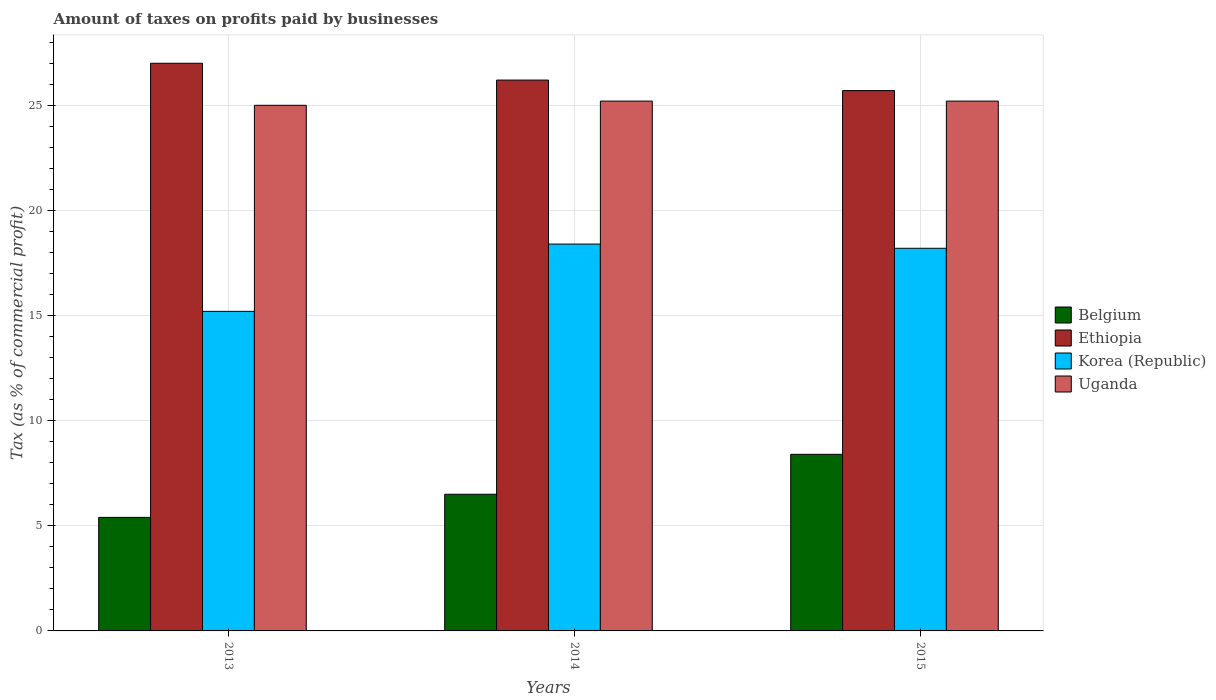Are the number of bars per tick equal to the number of legend labels?
Your answer should be very brief. Yes. Are the number of bars on each tick of the X-axis equal?
Your answer should be very brief. Yes. How many bars are there on the 2nd tick from the left?
Provide a succinct answer. 4. How many bars are there on the 1st tick from the right?
Your response must be concise. 4. What is the label of the 2nd group of bars from the left?
Make the answer very short. 2014. What is the percentage of taxes paid by businesses in Uganda in 2014?
Give a very brief answer. 25.2. In which year was the percentage of taxes paid by businesses in Uganda maximum?
Ensure brevity in your answer.  2014. In which year was the percentage of taxes paid by businesses in Ethiopia minimum?
Provide a succinct answer. 2015. What is the total percentage of taxes paid by businesses in Belgium in the graph?
Offer a terse response. 20.3. What is the difference between the percentage of taxes paid by businesses in Uganda in 2014 and that in 2015?
Your response must be concise. 0. What is the difference between the percentage of taxes paid by businesses in Ethiopia in 2015 and the percentage of taxes paid by businesses in Uganda in 2014?
Give a very brief answer. 0.5. What is the average percentage of taxes paid by businesses in Belgium per year?
Your answer should be compact. 6.77. In how many years, is the percentage of taxes paid by businesses in Belgium greater than 10 %?
Offer a very short reply. 0. What is the ratio of the percentage of taxes paid by businesses in Ethiopia in 2014 to that in 2015?
Give a very brief answer. 1.02. Is the percentage of taxes paid by businesses in Uganda in 2013 less than that in 2015?
Your response must be concise. Yes. What is the difference between the highest and the second highest percentage of taxes paid by businesses in Belgium?
Keep it short and to the point. 1.9. What is the difference between the highest and the lowest percentage of taxes paid by businesses in Uganda?
Your answer should be compact. 0.2. In how many years, is the percentage of taxes paid by businesses in Belgium greater than the average percentage of taxes paid by businesses in Belgium taken over all years?
Ensure brevity in your answer.  1. Is it the case that in every year, the sum of the percentage of taxes paid by businesses in Ethiopia and percentage of taxes paid by businesses in Korea (Republic) is greater than the sum of percentage of taxes paid by businesses in Uganda and percentage of taxes paid by businesses in Belgium?
Give a very brief answer. No. What does the 1st bar from the left in 2013 represents?
Keep it short and to the point. Belgium. How many years are there in the graph?
Your answer should be compact. 3. What is the difference between two consecutive major ticks on the Y-axis?
Keep it short and to the point. 5. Where does the legend appear in the graph?
Provide a short and direct response. Center right. How many legend labels are there?
Provide a short and direct response. 4. What is the title of the graph?
Give a very brief answer. Amount of taxes on profits paid by businesses. What is the label or title of the X-axis?
Provide a succinct answer. Years. What is the label or title of the Y-axis?
Keep it short and to the point. Tax (as % of commercial profit). What is the Tax (as % of commercial profit) of Belgium in 2013?
Give a very brief answer. 5.4. What is the Tax (as % of commercial profit) in Korea (Republic) in 2013?
Give a very brief answer. 15.2. What is the Tax (as % of commercial profit) in Uganda in 2013?
Keep it short and to the point. 25. What is the Tax (as % of commercial profit) of Ethiopia in 2014?
Make the answer very short. 26.2. What is the Tax (as % of commercial profit) of Korea (Republic) in 2014?
Ensure brevity in your answer.  18.4. What is the Tax (as % of commercial profit) of Uganda in 2014?
Provide a short and direct response. 25.2. What is the Tax (as % of commercial profit) of Ethiopia in 2015?
Give a very brief answer. 25.7. What is the Tax (as % of commercial profit) in Uganda in 2015?
Your answer should be compact. 25.2. Across all years, what is the maximum Tax (as % of commercial profit) of Belgium?
Your answer should be compact. 8.4. Across all years, what is the maximum Tax (as % of commercial profit) of Uganda?
Your response must be concise. 25.2. Across all years, what is the minimum Tax (as % of commercial profit) in Ethiopia?
Make the answer very short. 25.7. Across all years, what is the minimum Tax (as % of commercial profit) in Korea (Republic)?
Your answer should be compact. 15.2. What is the total Tax (as % of commercial profit) of Belgium in the graph?
Your answer should be compact. 20.3. What is the total Tax (as % of commercial profit) of Ethiopia in the graph?
Make the answer very short. 78.9. What is the total Tax (as % of commercial profit) of Korea (Republic) in the graph?
Offer a very short reply. 51.8. What is the total Tax (as % of commercial profit) of Uganda in the graph?
Give a very brief answer. 75.4. What is the difference between the Tax (as % of commercial profit) in Ethiopia in 2013 and that in 2014?
Your answer should be compact. 0.8. What is the difference between the Tax (as % of commercial profit) in Korea (Republic) in 2013 and that in 2014?
Give a very brief answer. -3.2. What is the difference between the Tax (as % of commercial profit) in Ethiopia in 2013 and that in 2015?
Offer a very short reply. 1.3. What is the difference between the Tax (as % of commercial profit) of Korea (Republic) in 2013 and that in 2015?
Give a very brief answer. -3. What is the difference between the Tax (as % of commercial profit) in Uganda in 2013 and that in 2015?
Ensure brevity in your answer.  -0.2. What is the difference between the Tax (as % of commercial profit) in Korea (Republic) in 2014 and that in 2015?
Offer a very short reply. 0.2. What is the difference between the Tax (as % of commercial profit) in Uganda in 2014 and that in 2015?
Provide a succinct answer. 0. What is the difference between the Tax (as % of commercial profit) of Belgium in 2013 and the Tax (as % of commercial profit) of Ethiopia in 2014?
Give a very brief answer. -20.8. What is the difference between the Tax (as % of commercial profit) of Belgium in 2013 and the Tax (as % of commercial profit) of Korea (Republic) in 2014?
Offer a terse response. -13. What is the difference between the Tax (as % of commercial profit) in Belgium in 2013 and the Tax (as % of commercial profit) in Uganda in 2014?
Ensure brevity in your answer.  -19.8. What is the difference between the Tax (as % of commercial profit) in Korea (Republic) in 2013 and the Tax (as % of commercial profit) in Uganda in 2014?
Ensure brevity in your answer.  -10. What is the difference between the Tax (as % of commercial profit) in Belgium in 2013 and the Tax (as % of commercial profit) in Ethiopia in 2015?
Ensure brevity in your answer.  -20.3. What is the difference between the Tax (as % of commercial profit) of Belgium in 2013 and the Tax (as % of commercial profit) of Uganda in 2015?
Make the answer very short. -19.8. What is the difference between the Tax (as % of commercial profit) of Belgium in 2014 and the Tax (as % of commercial profit) of Ethiopia in 2015?
Give a very brief answer. -19.2. What is the difference between the Tax (as % of commercial profit) of Belgium in 2014 and the Tax (as % of commercial profit) of Korea (Republic) in 2015?
Offer a very short reply. -11.7. What is the difference between the Tax (as % of commercial profit) in Belgium in 2014 and the Tax (as % of commercial profit) in Uganda in 2015?
Offer a terse response. -18.7. What is the difference between the Tax (as % of commercial profit) in Ethiopia in 2014 and the Tax (as % of commercial profit) in Korea (Republic) in 2015?
Make the answer very short. 8. What is the average Tax (as % of commercial profit) of Belgium per year?
Give a very brief answer. 6.77. What is the average Tax (as % of commercial profit) of Ethiopia per year?
Keep it short and to the point. 26.3. What is the average Tax (as % of commercial profit) in Korea (Republic) per year?
Your answer should be compact. 17.27. What is the average Tax (as % of commercial profit) in Uganda per year?
Offer a very short reply. 25.13. In the year 2013, what is the difference between the Tax (as % of commercial profit) of Belgium and Tax (as % of commercial profit) of Ethiopia?
Your response must be concise. -21.6. In the year 2013, what is the difference between the Tax (as % of commercial profit) in Belgium and Tax (as % of commercial profit) in Uganda?
Your response must be concise. -19.6. In the year 2013, what is the difference between the Tax (as % of commercial profit) in Ethiopia and Tax (as % of commercial profit) in Uganda?
Your response must be concise. 2. In the year 2013, what is the difference between the Tax (as % of commercial profit) in Korea (Republic) and Tax (as % of commercial profit) in Uganda?
Give a very brief answer. -9.8. In the year 2014, what is the difference between the Tax (as % of commercial profit) of Belgium and Tax (as % of commercial profit) of Ethiopia?
Give a very brief answer. -19.7. In the year 2014, what is the difference between the Tax (as % of commercial profit) in Belgium and Tax (as % of commercial profit) in Uganda?
Your answer should be very brief. -18.7. In the year 2014, what is the difference between the Tax (as % of commercial profit) of Korea (Republic) and Tax (as % of commercial profit) of Uganda?
Provide a short and direct response. -6.8. In the year 2015, what is the difference between the Tax (as % of commercial profit) of Belgium and Tax (as % of commercial profit) of Ethiopia?
Provide a succinct answer. -17.3. In the year 2015, what is the difference between the Tax (as % of commercial profit) in Belgium and Tax (as % of commercial profit) in Korea (Republic)?
Your answer should be very brief. -9.8. In the year 2015, what is the difference between the Tax (as % of commercial profit) of Belgium and Tax (as % of commercial profit) of Uganda?
Your answer should be very brief. -16.8. In the year 2015, what is the difference between the Tax (as % of commercial profit) in Ethiopia and Tax (as % of commercial profit) in Uganda?
Your answer should be very brief. 0.5. What is the ratio of the Tax (as % of commercial profit) of Belgium in 2013 to that in 2014?
Your response must be concise. 0.83. What is the ratio of the Tax (as % of commercial profit) of Ethiopia in 2013 to that in 2014?
Ensure brevity in your answer.  1.03. What is the ratio of the Tax (as % of commercial profit) of Korea (Republic) in 2013 to that in 2014?
Your answer should be compact. 0.83. What is the ratio of the Tax (as % of commercial profit) in Belgium in 2013 to that in 2015?
Offer a terse response. 0.64. What is the ratio of the Tax (as % of commercial profit) in Ethiopia in 2013 to that in 2015?
Your answer should be compact. 1.05. What is the ratio of the Tax (as % of commercial profit) of Korea (Republic) in 2013 to that in 2015?
Provide a short and direct response. 0.84. What is the ratio of the Tax (as % of commercial profit) of Uganda in 2013 to that in 2015?
Your response must be concise. 0.99. What is the ratio of the Tax (as % of commercial profit) of Belgium in 2014 to that in 2015?
Give a very brief answer. 0.77. What is the ratio of the Tax (as % of commercial profit) of Ethiopia in 2014 to that in 2015?
Keep it short and to the point. 1.02. What is the ratio of the Tax (as % of commercial profit) of Uganda in 2014 to that in 2015?
Give a very brief answer. 1. What is the difference between the highest and the second highest Tax (as % of commercial profit) of Korea (Republic)?
Provide a short and direct response. 0.2. What is the difference between the highest and the second highest Tax (as % of commercial profit) in Uganda?
Your answer should be compact. 0. What is the difference between the highest and the lowest Tax (as % of commercial profit) in Uganda?
Provide a succinct answer. 0.2. 